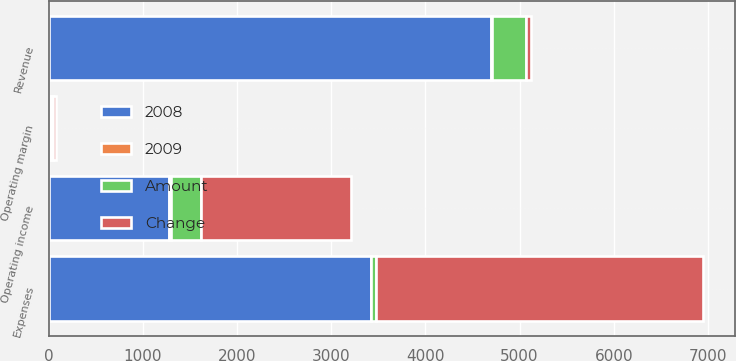<chart> <loc_0><loc_0><loc_500><loc_500><stacked_bar_chart><ecel><fcel>Revenue<fcel>Expenses<fcel>Operating income<fcel>Operating margin<nl><fcel>2008<fcel>4700<fcel>3422<fcel>1278<fcel>27.2<nl><fcel>Change<fcel>49<fcel>3471<fcel>1593<fcel>31.5<nl><fcel>Amount<fcel>364<fcel>49<fcel>315<fcel>4.3<nl><fcel>2009<fcel>7<fcel>1<fcel>20<fcel>14<nl></chart> 